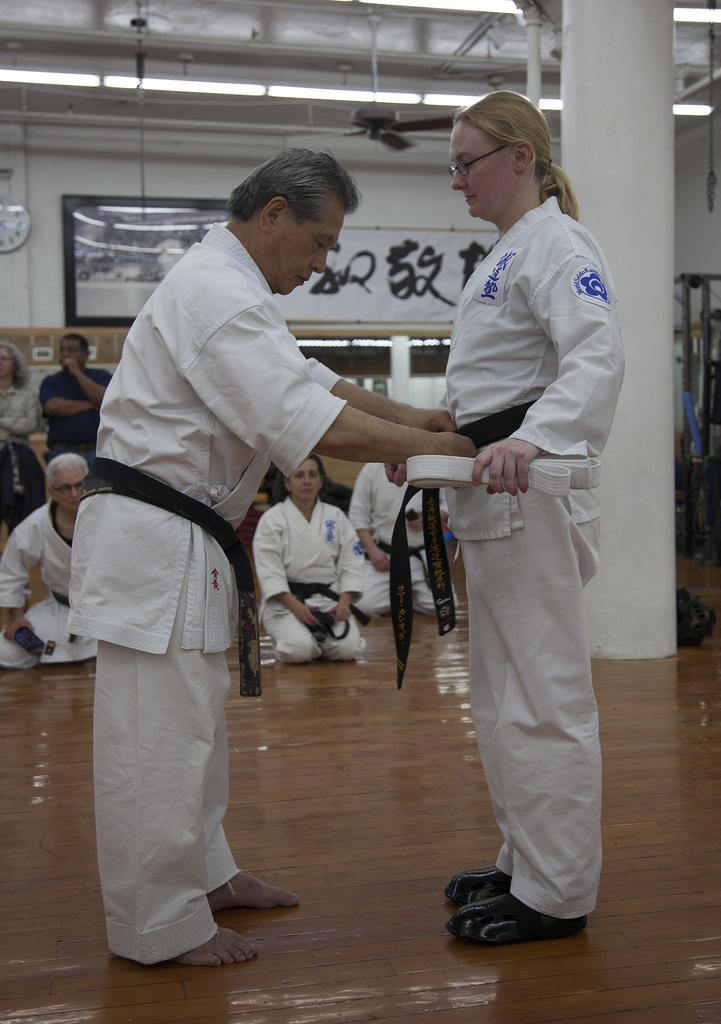How many people are present in the image? There are two people, a man and a woman, present in the image. What are the man and woman doing in the image? Both the man and woman are on the floor. Are there any other people in the image besides the man and woman? Yes, there are people sitting on the floor in the background. What type of lighting is visible in the image? Tube lights are visible at the top of the image. How many pies is the girl holding in the image? There is no girl present in the image, and therefore no pies can be held. 